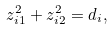<formula> <loc_0><loc_0><loc_500><loc_500>z _ { i 1 } ^ { 2 } + z _ { i 2 } ^ { 2 } = d _ { i } ,</formula> 